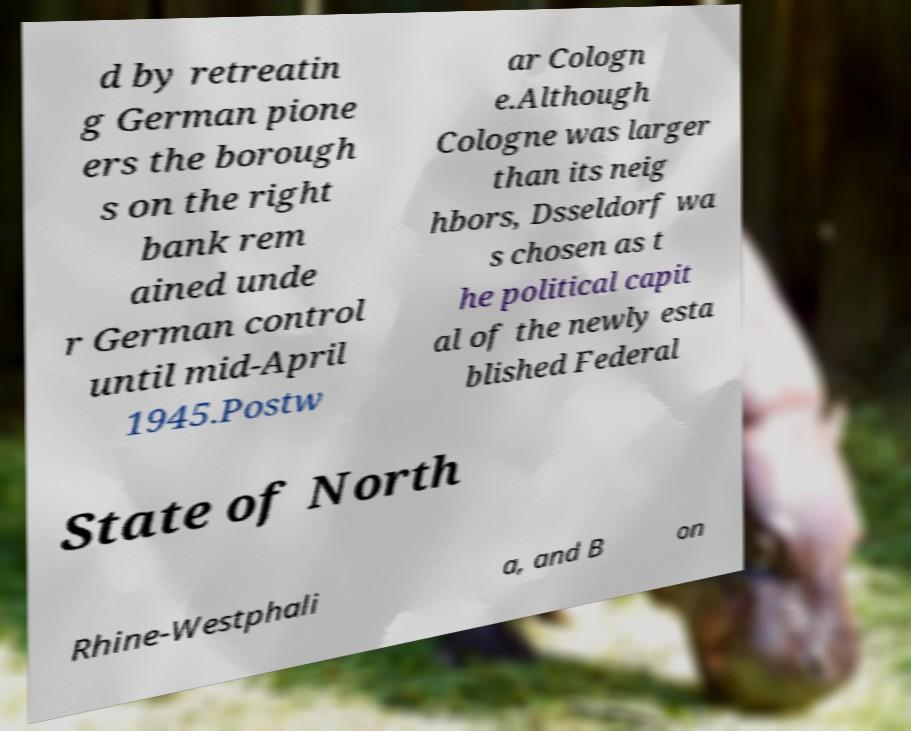Could you extract and type out the text from this image? d by retreatin g German pione ers the borough s on the right bank rem ained unde r German control until mid-April 1945.Postw ar Cologn e.Although Cologne was larger than its neig hbors, Dsseldorf wa s chosen as t he political capit al of the newly esta blished Federal State of North Rhine-Westphali a, and B on 